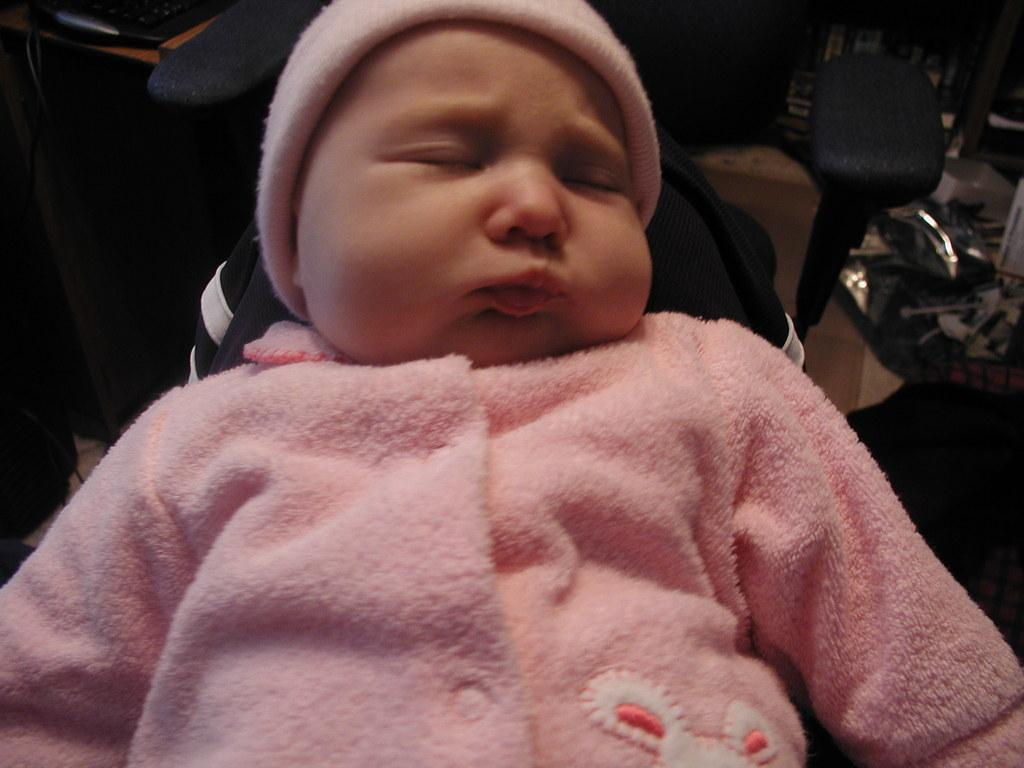What is the main subject of the image? There is a baby in the center of the image. What is the baby wearing on their head? The baby is wearing a cap. What color is the dress the baby is wearing? The baby is wearing a pink dress. Can you describe the background of the image? The background of the image is not clear. Is there a fireman partnered with the baby in the image? There is no fireman or any other person present in the image; it only features a baby. 